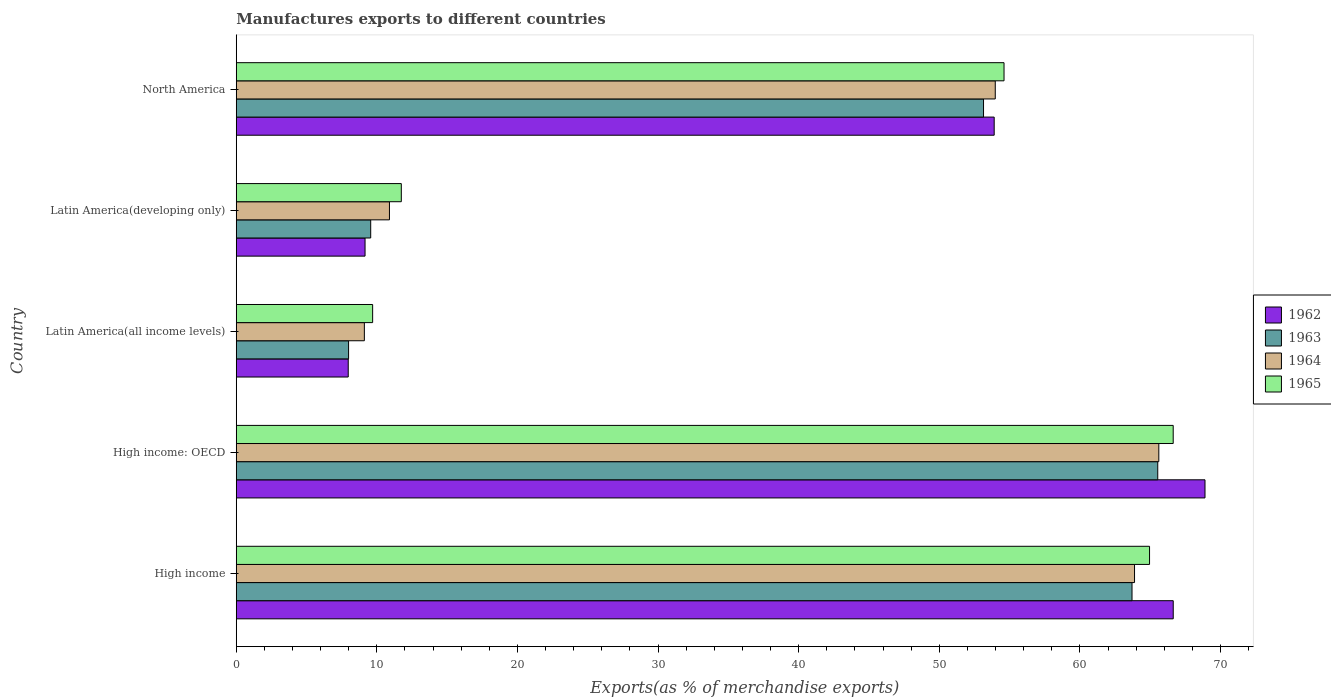How many different coloured bars are there?
Your answer should be very brief. 4. How many groups of bars are there?
Keep it short and to the point. 5. Are the number of bars on each tick of the Y-axis equal?
Make the answer very short. Yes. How many bars are there on the 5th tick from the bottom?
Provide a short and direct response. 4. What is the label of the 4th group of bars from the top?
Make the answer very short. High income: OECD. In how many cases, is the number of bars for a given country not equal to the number of legend labels?
Ensure brevity in your answer.  0. What is the percentage of exports to different countries in 1962 in High income: OECD?
Make the answer very short. 68.9. Across all countries, what is the maximum percentage of exports to different countries in 1963?
Make the answer very short. 65.54. Across all countries, what is the minimum percentage of exports to different countries in 1965?
Ensure brevity in your answer.  9.7. In which country was the percentage of exports to different countries in 1962 maximum?
Offer a very short reply. High income: OECD. In which country was the percentage of exports to different countries in 1962 minimum?
Keep it short and to the point. Latin America(all income levels). What is the total percentage of exports to different countries in 1964 in the graph?
Ensure brevity in your answer.  203.49. What is the difference between the percentage of exports to different countries in 1963 in Latin America(all income levels) and that in North America?
Provide a short and direct response. -45.16. What is the difference between the percentage of exports to different countries in 1962 in Latin America(developing only) and the percentage of exports to different countries in 1963 in North America?
Offer a very short reply. -43.99. What is the average percentage of exports to different countries in 1964 per country?
Give a very brief answer. 40.7. What is the difference between the percentage of exports to different countries in 1963 and percentage of exports to different countries in 1964 in North America?
Provide a short and direct response. -0.84. What is the ratio of the percentage of exports to different countries in 1963 in High income to that in Latin America(all income levels)?
Your answer should be very brief. 7.97. Is the difference between the percentage of exports to different countries in 1963 in High income and High income: OECD greater than the difference between the percentage of exports to different countries in 1964 in High income and High income: OECD?
Your response must be concise. No. What is the difference between the highest and the second highest percentage of exports to different countries in 1965?
Offer a terse response. 1.68. What is the difference between the highest and the lowest percentage of exports to different countries in 1965?
Keep it short and to the point. 56.94. Is the sum of the percentage of exports to different countries in 1962 in Latin America(developing only) and North America greater than the maximum percentage of exports to different countries in 1964 across all countries?
Your answer should be compact. No. Is it the case that in every country, the sum of the percentage of exports to different countries in 1963 and percentage of exports to different countries in 1964 is greater than the sum of percentage of exports to different countries in 1962 and percentage of exports to different countries in 1965?
Your answer should be very brief. No. What does the 2nd bar from the top in Latin America(developing only) represents?
Provide a short and direct response. 1964. What does the 3rd bar from the bottom in North America represents?
Provide a succinct answer. 1964. How many bars are there?
Your answer should be compact. 20. Are all the bars in the graph horizontal?
Your answer should be very brief. Yes. How many countries are there in the graph?
Provide a succinct answer. 5. What is the difference between two consecutive major ticks on the X-axis?
Offer a terse response. 10. Are the values on the major ticks of X-axis written in scientific E-notation?
Give a very brief answer. No. Does the graph contain any zero values?
Your answer should be very brief. No. Where does the legend appear in the graph?
Make the answer very short. Center right. How many legend labels are there?
Provide a short and direct response. 4. How are the legend labels stacked?
Provide a succinct answer. Vertical. What is the title of the graph?
Keep it short and to the point. Manufactures exports to different countries. What is the label or title of the X-axis?
Keep it short and to the point. Exports(as % of merchandise exports). What is the Exports(as % of merchandise exports) of 1962 in High income?
Keep it short and to the point. 66.64. What is the Exports(as % of merchandise exports) in 1963 in High income?
Offer a terse response. 63.71. What is the Exports(as % of merchandise exports) of 1964 in High income?
Your answer should be compact. 63.89. What is the Exports(as % of merchandise exports) in 1965 in High income?
Offer a very short reply. 64.96. What is the Exports(as % of merchandise exports) in 1962 in High income: OECD?
Ensure brevity in your answer.  68.9. What is the Exports(as % of merchandise exports) in 1963 in High income: OECD?
Ensure brevity in your answer.  65.54. What is the Exports(as % of merchandise exports) in 1964 in High income: OECD?
Your response must be concise. 65.61. What is the Exports(as % of merchandise exports) in 1965 in High income: OECD?
Make the answer very short. 66.64. What is the Exports(as % of merchandise exports) in 1962 in Latin America(all income levels)?
Offer a very short reply. 7.96. What is the Exports(as % of merchandise exports) in 1963 in Latin America(all income levels)?
Your answer should be very brief. 7.99. What is the Exports(as % of merchandise exports) of 1964 in Latin America(all income levels)?
Provide a short and direct response. 9.11. What is the Exports(as % of merchandise exports) of 1965 in Latin America(all income levels)?
Keep it short and to the point. 9.7. What is the Exports(as % of merchandise exports) of 1962 in Latin America(developing only)?
Ensure brevity in your answer.  9.16. What is the Exports(as % of merchandise exports) in 1963 in Latin America(developing only)?
Your answer should be compact. 9.56. What is the Exports(as % of merchandise exports) of 1964 in Latin America(developing only)?
Your response must be concise. 10.9. What is the Exports(as % of merchandise exports) of 1965 in Latin America(developing only)?
Your answer should be very brief. 11.74. What is the Exports(as % of merchandise exports) in 1962 in North America?
Provide a short and direct response. 53.91. What is the Exports(as % of merchandise exports) in 1963 in North America?
Provide a short and direct response. 53.15. What is the Exports(as % of merchandise exports) in 1964 in North America?
Make the answer very short. 53.98. What is the Exports(as % of merchandise exports) in 1965 in North America?
Offer a very short reply. 54.61. Across all countries, what is the maximum Exports(as % of merchandise exports) in 1962?
Give a very brief answer. 68.9. Across all countries, what is the maximum Exports(as % of merchandise exports) of 1963?
Offer a very short reply. 65.54. Across all countries, what is the maximum Exports(as % of merchandise exports) of 1964?
Your response must be concise. 65.61. Across all countries, what is the maximum Exports(as % of merchandise exports) in 1965?
Your answer should be compact. 66.64. Across all countries, what is the minimum Exports(as % of merchandise exports) in 1962?
Give a very brief answer. 7.96. Across all countries, what is the minimum Exports(as % of merchandise exports) of 1963?
Offer a terse response. 7.99. Across all countries, what is the minimum Exports(as % of merchandise exports) in 1964?
Your answer should be compact. 9.11. Across all countries, what is the minimum Exports(as % of merchandise exports) of 1965?
Provide a succinct answer. 9.7. What is the total Exports(as % of merchandise exports) in 1962 in the graph?
Your answer should be compact. 206.57. What is the total Exports(as % of merchandise exports) of 1963 in the graph?
Offer a very short reply. 199.94. What is the total Exports(as % of merchandise exports) of 1964 in the graph?
Provide a succinct answer. 203.49. What is the total Exports(as % of merchandise exports) in 1965 in the graph?
Make the answer very short. 207.64. What is the difference between the Exports(as % of merchandise exports) in 1962 in High income and that in High income: OECD?
Keep it short and to the point. -2.26. What is the difference between the Exports(as % of merchandise exports) of 1963 in High income and that in High income: OECD?
Provide a short and direct response. -1.83. What is the difference between the Exports(as % of merchandise exports) of 1964 in High income and that in High income: OECD?
Provide a short and direct response. -1.73. What is the difference between the Exports(as % of merchandise exports) in 1965 in High income and that in High income: OECD?
Your answer should be compact. -1.68. What is the difference between the Exports(as % of merchandise exports) in 1962 in High income and that in Latin America(all income levels)?
Your response must be concise. 58.68. What is the difference between the Exports(as % of merchandise exports) of 1963 in High income and that in Latin America(all income levels)?
Make the answer very short. 55.72. What is the difference between the Exports(as % of merchandise exports) in 1964 in High income and that in Latin America(all income levels)?
Keep it short and to the point. 54.78. What is the difference between the Exports(as % of merchandise exports) of 1965 in High income and that in Latin America(all income levels)?
Keep it short and to the point. 55.25. What is the difference between the Exports(as % of merchandise exports) of 1962 in High income and that in Latin America(developing only)?
Offer a terse response. 57.48. What is the difference between the Exports(as % of merchandise exports) in 1963 in High income and that in Latin America(developing only)?
Provide a succinct answer. 54.15. What is the difference between the Exports(as % of merchandise exports) of 1964 in High income and that in Latin America(developing only)?
Give a very brief answer. 52.99. What is the difference between the Exports(as % of merchandise exports) in 1965 in High income and that in Latin America(developing only)?
Your answer should be very brief. 53.22. What is the difference between the Exports(as % of merchandise exports) of 1962 in High income and that in North America?
Give a very brief answer. 12.73. What is the difference between the Exports(as % of merchandise exports) of 1963 in High income and that in North America?
Give a very brief answer. 10.56. What is the difference between the Exports(as % of merchandise exports) in 1964 in High income and that in North America?
Make the answer very short. 9.9. What is the difference between the Exports(as % of merchandise exports) of 1965 in High income and that in North America?
Your answer should be compact. 10.35. What is the difference between the Exports(as % of merchandise exports) in 1962 in High income: OECD and that in Latin America(all income levels)?
Keep it short and to the point. 60.93. What is the difference between the Exports(as % of merchandise exports) in 1963 in High income: OECD and that in Latin America(all income levels)?
Give a very brief answer. 57.55. What is the difference between the Exports(as % of merchandise exports) in 1964 in High income: OECD and that in Latin America(all income levels)?
Ensure brevity in your answer.  56.5. What is the difference between the Exports(as % of merchandise exports) of 1965 in High income: OECD and that in Latin America(all income levels)?
Your answer should be compact. 56.94. What is the difference between the Exports(as % of merchandise exports) of 1962 in High income: OECD and that in Latin America(developing only)?
Provide a succinct answer. 59.74. What is the difference between the Exports(as % of merchandise exports) of 1963 in High income: OECD and that in Latin America(developing only)?
Offer a very short reply. 55.98. What is the difference between the Exports(as % of merchandise exports) in 1964 in High income: OECD and that in Latin America(developing only)?
Keep it short and to the point. 54.72. What is the difference between the Exports(as % of merchandise exports) of 1965 in High income: OECD and that in Latin America(developing only)?
Provide a short and direct response. 54.9. What is the difference between the Exports(as % of merchandise exports) of 1962 in High income: OECD and that in North America?
Your response must be concise. 14.99. What is the difference between the Exports(as % of merchandise exports) in 1963 in High income: OECD and that in North America?
Your response must be concise. 12.39. What is the difference between the Exports(as % of merchandise exports) of 1964 in High income: OECD and that in North America?
Your response must be concise. 11.63. What is the difference between the Exports(as % of merchandise exports) of 1965 in High income: OECD and that in North America?
Give a very brief answer. 12.03. What is the difference between the Exports(as % of merchandise exports) of 1962 in Latin America(all income levels) and that in Latin America(developing only)?
Ensure brevity in your answer.  -1.2. What is the difference between the Exports(as % of merchandise exports) of 1963 in Latin America(all income levels) and that in Latin America(developing only)?
Offer a terse response. -1.57. What is the difference between the Exports(as % of merchandise exports) of 1964 in Latin America(all income levels) and that in Latin America(developing only)?
Give a very brief answer. -1.78. What is the difference between the Exports(as % of merchandise exports) in 1965 in Latin America(all income levels) and that in Latin America(developing only)?
Provide a short and direct response. -2.04. What is the difference between the Exports(as % of merchandise exports) in 1962 in Latin America(all income levels) and that in North America?
Make the answer very short. -45.94. What is the difference between the Exports(as % of merchandise exports) of 1963 in Latin America(all income levels) and that in North America?
Your answer should be very brief. -45.16. What is the difference between the Exports(as % of merchandise exports) of 1964 in Latin America(all income levels) and that in North America?
Offer a terse response. -44.87. What is the difference between the Exports(as % of merchandise exports) in 1965 in Latin America(all income levels) and that in North America?
Keep it short and to the point. -44.91. What is the difference between the Exports(as % of merchandise exports) of 1962 in Latin America(developing only) and that in North America?
Your answer should be compact. -44.75. What is the difference between the Exports(as % of merchandise exports) in 1963 in Latin America(developing only) and that in North America?
Your response must be concise. -43.59. What is the difference between the Exports(as % of merchandise exports) in 1964 in Latin America(developing only) and that in North America?
Keep it short and to the point. -43.09. What is the difference between the Exports(as % of merchandise exports) in 1965 in Latin America(developing only) and that in North America?
Provide a succinct answer. -42.87. What is the difference between the Exports(as % of merchandise exports) in 1962 in High income and the Exports(as % of merchandise exports) in 1963 in High income: OECD?
Make the answer very short. 1.1. What is the difference between the Exports(as % of merchandise exports) in 1962 in High income and the Exports(as % of merchandise exports) in 1964 in High income: OECD?
Provide a short and direct response. 1.03. What is the difference between the Exports(as % of merchandise exports) of 1962 in High income and the Exports(as % of merchandise exports) of 1965 in High income: OECD?
Offer a terse response. 0. What is the difference between the Exports(as % of merchandise exports) of 1963 in High income and the Exports(as % of merchandise exports) of 1964 in High income: OECD?
Provide a succinct answer. -1.91. What is the difference between the Exports(as % of merchandise exports) in 1963 in High income and the Exports(as % of merchandise exports) in 1965 in High income: OECD?
Offer a very short reply. -2.93. What is the difference between the Exports(as % of merchandise exports) of 1964 in High income and the Exports(as % of merchandise exports) of 1965 in High income: OECD?
Give a very brief answer. -2.75. What is the difference between the Exports(as % of merchandise exports) of 1962 in High income and the Exports(as % of merchandise exports) of 1963 in Latin America(all income levels)?
Your answer should be very brief. 58.65. What is the difference between the Exports(as % of merchandise exports) in 1962 in High income and the Exports(as % of merchandise exports) in 1964 in Latin America(all income levels)?
Offer a terse response. 57.53. What is the difference between the Exports(as % of merchandise exports) of 1962 in High income and the Exports(as % of merchandise exports) of 1965 in Latin America(all income levels)?
Ensure brevity in your answer.  56.94. What is the difference between the Exports(as % of merchandise exports) of 1963 in High income and the Exports(as % of merchandise exports) of 1964 in Latin America(all income levels)?
Your answer should be compact. 54.6. What is the difference between the Exports(as % of merchandise exports) of 1963 in High income and the Exports(as % of merchandise exports) of 1965 in Latin America(all income levels)?
Offer a terse response. 54.01. What is the difference between the Exports(as % of merchandise exports) in 1964 in High income and the Exports(as % of merchandise exports) in 1965 in Latin America(all income levels)?
Provide a succinct answer. 54.19. What is the difference between the Exports(as % of merchandise exports) in 1962 in High income and the Exports(as % of merchandise exports) in 1963 in Latin America(developing only)?
Keep it short and to the point. 57.08. What is the difference between the Exports(as % of merchandise exports) in 1962 in High income and the Exports(as % of merchandise exports) in 1964 in Latin America(developing only)?
Your answer should be very brief. 55.74. What is the difference between the Exports(as % of merchandise exports) in 1962 in High income and the Exports(as % of merchandise exports) in 1965 in Latin America(developing only)?
Keep it short and to the point. 54.9. What is the difference between the Exports(as % of merchandise exports) in 1963 in High income and the Exports(as % of merchandise exports) in 1964 in Latin America(developing only)?
Ensure brevity in your answer.  52.81. What is the difference between the Exports(as % of merchandise exports) of 1963 in High income and the Exports(as % of merchandise exports) of 1965 in Latin America(developing only)?
Provide a short and direct response. 51.97. What is the difference between the Exports(as % of merchandise exports) of 1964 in High income and the Exports(as % of merchandise exports) of 1965 in Latin America(developing only)?
Your answer should be compact. 52.15. What is the difference between the Exports(as % of merchandise exports) of 1962 in High income and the Exports(as % of merchandise exports) of 1963 in North America?
Keep it short and to the point. 13.49. What is the difference between the Exports(as % of merchandise exports) in 1962 in High income and the Exports(as % of merchandise exports) in 1964 in North America?
Offer a terse response. 12.66. What is the difference between the Exports(as % of merchandise exports) of 1962 in High income and the Exports(as % of merchandise exports) of 1965 in North America?
Make the answer very short. 12.03. What is the difference between the Exports(as % of merchandise exports) in 1963 in High income and the Exports(as % of merchandise exports) in 1964 in North America?
Give a very brief answer. 9.73. What is the difference between the Exports(as % of merchandise exports) in 1963 in High income and the Exports(as % of merchandise exports) in 1965 in North America?
Provide a short and direct response. 9.1. What is the difference between the Exports(as % of merchandise exports) of 1964 in High income and the Exports(as % of merchandise exports) of 1965 in North America?
Offer a terse response. 9.28. What is the difference between the Exports(as % of merchandise exports) of 1962 in High income: OECD and the Exports(as % of merchandise exports) of 1963 in Latin America(all income levels)?
Offer a terse response. 60.91. What is the difference between the Exports(as % of merchandise exports) of 1962 in High income: OECD and the Exports(as % of merchandise exports) of 1964 in Latin America(all income levels)?
Keep it short and to the point. 59.79. What is the difference between the Exports(as % of merchandise exports) in 1962 in High income: OECD and the Exports(as % of merchandise exports) in 1965 in Latin America(all income levels)?
Provide a succinct answer. 59.2. What is the difference between the Exports(as % of merchandise exports) in 1963 in High income: OECD and the Exports(as % of merchandise exports) in 1964 in Latin America(all income levels)?
Offer a terse response. 56.43. What is the difference between the Exports(as % of merchandise exports) of 1963 in High income: OECD and the Exports(as % of merchandise exports) of 1965 in Latin America(all income levels)?
Offer a very short reply. 55.84. What is the difference between the Exports(as % of merchandise exports) of 1964 in High income: OECD and the Exports(as % of merchandise exports) of 1965 in Latin America(all income levels)?
Offer a very short reply. 55.91. What is the difference between the Exports(as % of merchandise exports) of 1962 in High income: OECD and the Exports(as % of merchandise exports) of 1963 in Latin America(developing only)?
Offer a terse response. 59.34. What is the difference between the Exports(as % of merchandise exports) in 1962 in High income: OECD and the Exports(as % of merchandise exports) in 1964 in Latin America(developing only)?
Keep it short and to the point. 58. What is the difference between the Exports(as % of merchandise exports) in 1962 in High income: OECD and the Exports(as % of merchandise exports) in 1965 in Latin America(developing only)?
Give a very brief answer. 57.16. What is the difference between the Exports(as % of merchandise exports) of 1963 in High income: OECD and the Exports(as % of merchandise exports) of 1964 in Latin America(developing only)?
Your answer should be very brief. 54.64. What is the difference between the Exports(as % of merchandise exports) in 1963 in High income: OECD and the Exports(as % of merchandise exports) in 1965 in Latin America(developing only)?
Your answer should be very brief. 53.8. What is the difference between the Exports(as % of merchandise exports) of 1964 in High income: OECD and the Exports(as % of merchandise exports) of 1965 in Latin America(developing only)?
Make the answer very short. 53.87. What is the difference between the Exports(as % of merchandise exports) of 1962 in High income: OECD and the Exports(as % of merchandise exports) of 1963 in North America?
Your answer should be very brief. 15.75. What is the difference between the Exports(as % of merchandise exports) of 1962 in High income: OECD and the Exports(as % of merchandise exports) of 1964 in North America?
Your response must be concise. 14.92. What is the difference between the Exports(as % of merchandise exports) in 1962 in High income: OECD and the Exports(as % of merchandise exports) in 1965 in North America?
Provide a succinct answer. 14.29. What is the difference between the Exports(as % of merchandise exports) in 1963 in High income: OECD and the Exports(as % of merchandise exports) in 1964 in North America?
Provide a succinct answer. 11.56. What is the difference between the Exports(as % of merchandise exports) of 1963 in High income: OECD and the Exports(as % of merchandise exports) of 1965 in North America?
Offer a terse response. 10.93. What is the difference between the Exports(as % of merchandise exports) in 1964 in High income: OECD and the Exports(as % of merchandise exports) in 1965 in North America?
Keep it short and to the point. 11.01. What is the difference between the Exports(as % of merchandise exports) of 1962 in Latin America(all income levels) and the Exports(as % of merchandise exports) of 1963 in Latin America(developing only)?
Keep it short and to the point. -1.6. What is the difference between the Exports(as % of merchandise exports) in 1962 in Latin America(all income levels) and the Exports(as % of merchandise exports) in 1964 in Latin America(developing only)?
Your response must be concise. -2.93. What is the difference between the Exports(as % of merchandise exports) of 1962 in Latin America(all income levels) and the Exports(as % of merchandise exports) of 1965 in Latin America(developing only)?
Offer a very short reply. -3.78. What is the difference between the Exports(as % of merchandise exports) of 1963 in Latin America(all income levels) and the Exports(as % of merchandise exports) of 1964 in Latin America(developing only)?
Give a very brief answer. -2.91. What is the difference between the Exports(as % of merchandise exports) of 1963 in Latin America(all income levels) and the Exports(as % of merchandise exports) of 1965 in Latin America(developing only)?
Provide a succinct answer. -3.75. What is the difference between the Exports(as % of merchandise exports) of 1964 in Latin America(all income levels) and the Exports(as % of merchandise exports) of 1965 in Latin America(developing only)?
Offer a very short reply. -2.63. What is the difference between the Exports(as % of merchandise exports) in 1962 in Latin America(all income levels) and the Exports(as % of merchandise exports) in 1963 in North America?
Make the answer very short. -45.18. What is the difference between the Exports(as % of merchandise exports) of 1962 in Latin America(all income levels) and the Exports(as % of merchandise exports) of 1964 in North America?
Ensure brevity in your answer.  -46.02. What is the difference between the Exports(as % of merchandise exports) of 1962 in Latin America(all income levels) and the Exports(as % of merchandise exports) of 1965 in North America?
Provide a short and direct response. -46.64. What is the difference between the Exports(as % of merchandise exports) of 1963 in Latin America(all income levels) and the Exports(as % of merchandise exports) of 1964 in North America?
Give a very brief answer. -45.99. What is the difference between the Exports(as % of merchandise exports) of 1963 in Latin America(all income levels) and the Exports(as % of merchandise exports) of 1965 in North America?
Your response must be concise. -46.62. What is the difference between the Exports(as % of merchandise exports) in 1964 in Latin America(all income levels) and the Exports(as % of merchandise exports) in 1965 in North America?
Your response must be concise. -45.49. What is the difference between the Exports(as % of merchandise exports) of 1962 in Latin America(developing only) and the Exports(as % of merchandise exports) of 1963 in North America?
Provide a short and direct response. -43.99. What is the difference between the Exports(as % of merchandise exports) of 1962 in Latin America(developing only) and the Exports(as % of merchandise exports) of 1964 in North America?
Ensure brevity in your answer.  -44.82. What is the difference between the Exports(as % of merchandise exports) in 1962 in Latin America(developing only) and the Exports(as % of merchandise exports) in 1965 in North America?
Your answer should be compact. -45.45. What is the difference between the Exports(as % of merchandise exports) of 1963 in Latin America(developing only) and the Exports(as % of merchandise exports) of 1964 in North America?
Your answer should be compact. -44.42. What is the difference between the Exports(as % of merchandise exports) of 1963 in Latin America(developing only) and the Exports(as % of merchandise exports) of 1965 in North America?
Your response must be concise. -45.04. What is the difference between the Exports(as % of merchandise exports) of 1964 in Latin America(developing only) and the Exports(as % of merchandise exports) of 1965 in North America?
Keep it short and to the point. -43.71. What is the average Exports(as % of merchandise exports) in 1962 per country?
Ensure brevity in your answer.  41.31. What is the average Exports(as % of merchandise exports) of 1963 per country?
Provide a succinct answer. 39.99. What is the average Exports(as % of merchandise exports) of 1964 per country?
Ensure brevity in your answer.  40.7. What is the average Exports(as % of merchandise exports) of 1965 per country?
Provide a succinct answer. 41.53. What is the difference between the Exports(as % of merchandise exports) in 1962 and Exports(as % of merchandise exports) in 1963 in High income?
Your answer should be very brief. 2.93. What is the difference between the Exports(as % of merchandise exports) of 1962 and Exports(as % of merchandise exports) of 1964 in High income?
Your response must be concise. 2.75. What is the difference between the Exports(as % of merchandise exports) in 1962 and Exports(as % of merchandise exports) in 1965 in High income?
Offer a terse response. 1.68. What is the difference between the Exports(as % of merchandise exports) of 1963 and Exports(as % of merchandise exports) of 1964 in High income?
Ensure brevity in your answer.  -0.18. What is the difference between the Exports(as % of merchandise exports) of 1963 and Exports(as % of merchandise exports) of 1965 in High income?
Give a very brief answer. -1.25. What is the difference between the Exports(as % of merchandise exports) of 1964 and Exports(as % of merchandise exports) of 1965 in High income?
Your response must be concise. -1.07. What is the difference between the Exports(as % of merchandise exports) in 1962 and Exports(as % of merchandise exports) in 1963 in High income: OECD?
Give a very brief answer. 3.36. What is the difference between the Exports(as % of merchandise exports) in 1962 and Exports(as % of merchandise exports) in 1964 in High income: OECD?
Offer a very short reply. 3.28. What is the difference between the Exports(as % of merchandise exports) of 1962 and Exports(as % of merchandise exports) of 1965 in High income: OECD?
Your answer should be compact. 2.26. What is the difference between the Exports(as % of merchandise exports) in 1963 and Exports(as % of merchandise exports) in 1964 in High income: OECD?
Ensure brevity in your answer.  -0.08. What is the difference between the Exports(as % of merchandise exports) in 1963 and Exports(as % of merchandise exports) in 1965 in High income: OECD?
Your answer should be compact. -1.1. What is the difference between the Exports(as % of merchandise exports) in 1964 and Exports(as % of merchandise exports) in 1965 in High income: OECD?
Provide a succinct answer. -1.02. What is the difference between the Exports(as % of merchandise exports) of 1962 and Exports(as % of merchandise exports) of 1963 in Latin America(all income levels)?
Your answer should be very brief. -0.02. What is the difference between the Exports(as % of merchandise exports) in 1962 and Exports(as % of merchandise exports) in 1964 in Latin America(all income levels)?
Your response must be concise. -1.15. What is the difference between the Exports(as % of merchandise exports) of 1962 and Exports(as % of merchandise exports) of 1965 in Latin America(all income levels)?
Keep it short and to the point. -1.74. What is the difference between the Exports(as % of merchandise exports) of 1963 and Exports(as % of merchandise exports) of 1964 in Latin America(all income levels)?
Give a very brief answer. -1.12. What is the difference between the Exports(as % of merchandise exports) in 1963 and Exports(as % of merchandise exports) in 1965 in Latin America(all income levels)?
Offer a very short reply. -1.71. What is the difference between the Exports(as % of merchandise exports) of 1964 and Exports(as % of merchandise exports) of 1965 in Latin America(all income levels)?
Provide a short and direct response. -0.59. What is the difference between the Exports(as % of merchandise exports) in 1962 and Exports(as % of merchandise exports) in 1963 in Latin America(developing only)?
Offer a terse response. -0.4. What is the difference between the Exports(as % of merchandise exports) of 1962 and Exports(as % of merchandise exports) of 1964 in Latin America(developing only)?
Offer a very short reply. -1.74. What is the difference between the Exports(as % of merchandise exports) of 1962 and Exports(as % of merchandise exports) of 1965 in Latin America(developing only)?
Give a very brief answer. -2.58. What is the difference between the Exports(as % of merchandise exports) in 1963 and Exports(as % of merchandise exports) in 1964 in Latin America(developing only)?
Your answer should be compact. -1.33. What is the difference between the Exports(as % of merchandise exports) of 1963 and Exports(as % of merchandise exports) of 1965 in Latin America(developing only)?
Keep it short and to the point. -2.18. What is the difference between the Exports(as % of merchandise exports) of 1964 and Exports(as % of merchandise exports) of 1965 in Latin America(developing only)?
Offer a very short reply. -0.84. What is the difference between the Exports(as % of merchandise exports) of 1962 and Exports(as % of merchandise exports) of 1963 in North America?
Offer a very short reply. 0.76. What is the difference between the Exports(as % of merchandise exports) of 1962 and Exports(as % of merchandise exports) of 1964 in North America?
Keep it short and to the point. -0.08. What is the difference between the Exports(as % of merchandise exports) of 1962 and Exports(as % of merchandise exports) of 1965 in North America?
Give a very brief answer. -0.7. What is the difference between the Exports(as % of merchandise exports) in 1963 and Exports(as % of merchandise exports) in 1964 in North America?
Provide a short and direct response. -0.84. What is the difference between the Exports(as % of merchandise exports) of 1963 and Exports(as % of merchandise exports) of 1965 in North America?
Your response must be concise. -1.46. What is the difference between the Exports(as % of merchandise exports) in 1964 and Exports(as % of merchandise exports) in 1965 in North America?
Keep it short and to the point. -0.62. What is the ratio of the Exports(as % of merchandise exports) in 1962 in High income to that in High income: OECD?
Your response must be concise. 0.97. What is the ratio of the Exports(as % of merchandise exports) in 1963 in High income to that in High income: OECD?
Make the answer very short. 0.97. What is the ratio of the Exports(as % of merchandise exports) of 1964 in High income to that in High income: OECD?
Give a very brief answer. 0.97. What is the ratio of the Exports(as % of merchandise exports) of 1965 in High income to that in High income: OECD?
Provide a short and direct response. 0.97. What is the ratio of the Exports(as % of merchandise exports) of 1962 in High income to that in Latin America(all income levels)?
Provide a short and direct response. 8.37. What is the ratio of the Exports(as % of merchandise exports) in 1963 in High income to that in Latin America(all income levels)?
Provide a short and direct response. 7.97. What is the ratio of the Exports(as % of merchandise exports) in 1964 in High income to that in Latin America(all income levels)?
Provide a succinct answer. 7.01. What is the ratio of the Exports(as % of merchandise exports) of 1965 in High income to that in Latin America(all income levels)?
Your response must be concise. 6.7. What is the ratio of the Exports(as % of merchandise exports) of 1962 in High income to that in Latin America(developing only)?
Give a very brief answer. 7.28. What is the ratio of the Exports(as % of merchandise exports) in 1963 in High income to that in Latin America(developing only)?
Offer a terse response. 6.66. What is the ratio of the Exports(as % of merchandise exports) of 1964 in High income to that in Latin America(developing only)?
Provide a short and direct response. 5.86. What is the ratio of the Exports(as % of merchandise exports) of 1965 in High income to that in Latin America(developing only)?
Provide a short and direct response. 5.53. What is the ratio of the Exports(as % of merchandise exports) of 1962 in High income to that in North America?
Give a very brief answer. 1.24. What is the ratio of the Exports(as % of merchandise exports) of 1963 in High income to that in North America?
Make the answer very short. 1.2. What is the ratio of the Exports(as % of merchandise exports) of 1964 in High income to that in North America?
Ensure brevity in your answer.  1.18. What is the ratio of the Exports(as % of merchandise exports) in 1965 in High income to that in North America?
Give a very brief answer. 1.19. What is the ratio of the Exports(as % of merchandise exports) of 1962 in High income: OECD to that in Latin America(all income levels)?
Offer a very short reply. 8.65. What is the ratio of the Exports(as % of merchandise exports) of 1963 in High income: OECD to that in Latin America(all income levels)?
Give a very brief answer. 8.2. What is the ratio of the Exports(as % of merchandise exports) of 1964 in High income: OECD to that in Latin America(all income levels)?
Your answer should be compact. 7.2. What is the ratio of the Exports(as % of merchandise exports) in 1965 in High income: OECD to that in Latin America(all income levels)?
Provide a succinct answer. 6.87. What is the ratio of the Exports(as % of merchandise exports) of 1962 in High income: OECD to that in Latin America(developing only)?
Give a very brief answer. 7.52. What is the ratio of the Exports(as % of merchandise exports) in 1963 in High income: OECD to that in Latin America(developing only)?
Provide a short and direct response. 6.85. What is the ratio of the Exports(as % of merchandise exports) in 1964 in High income: OECD to that in Latin America(developing only)?
Ensure brevity in your answer.  6.02. What is the ratio of the Exports(as % of merchandise exports) of 1965 in High income: OECD to that in Latin America(developing only)?
Offer a very short reply. 5.68. What is the ratio of the Exports(as % of merchandise exports) in 1962 in High income: OECD to that in North America?
Your answer should be compact. 1.28. What is the ratio of the Exports(as % of merchandise exports) in 1963 in High income: OECD to that in North America?
Ensure brevity in your answer.  1.23. What is the ratio of the Exports(as % of merchandise exports) in 1964 in High income: OECD to that in North America?
Your answer should be very brief. 1.22. What is the ratio of the Exports(as % of merchandise exports) of 1965 in High income: OECD to that in North America?
Offer a very short reply. 1.22. What is the ratio of the Exports(as % of merchandise exports) in 1962 in Latin America(all income levels) to that in Latin America(developing only)?
Offer a very short reply. 0.87. What is the ratio of the Exports(as % of merchandise exports) in 1963 in Latin America(all income levels) to that in Latin America(developing only)?
Your answer should be very brief. 0.84. What is the ratio of the Exports(as % of merchandise exports) of 1964 in Latin America(all income levels) to that in Latin America(developing only)?
Your response must be concise. 0.84. What is the ratio of the Exports(as % of merchandise exports) in 1965 in Latin America(all income levels) to that in Latin America(developing only)?
Your answer should be very brief. 0.83. What is the ratio of the Exports(as % of merchandise exports) in 1962 in Latin America(all income levels) to that in North America?
Your answer should be compact. 0.15. What is the ratio of the Exports(as % of merchandise exports) of 1963 in Latin America(all income levels) to that in North America?
Keep it short and to the point. 0.15. What is the ratio of the Exports(as % of merchandise exports) of 1964 in Latin America(all income levels) to that in North America?
Your response must be concise. 0.17. What is the ratio of the Exports(as % of merchandise exports) of 1965 in Latin America(all income levels) to that in North America?
Your answer should be compact. 0.18. What is the ratio of the Exports(as % of merchandise exports) in 1962 in Latin America(developing only) to that in North America?
Keep it short and to the point. 0.17. What is the ratio of the Exports(as % of merchandise exports) of 1963 in Latin America(developing only) to that in North America?
Provide a succinct answer. 0.18. What is the ratio of the Exports(as % of merchandise exports) of 1964 in Latin America(developing only) to that in North America?
Your answer should be compact. 0.2. What is the ratio of the Exports(as % of merchandise exports) in 1965 in Latin America(developing only) to that in North America?
Offer a terse response. 0.21. What is the difference between the highest and the second highest Exports(as % of merchandise exports) in 1962?
Keep it short and to the point. 2.26. What is the difference between the highest and the second highest Exports(as % of merchandise exports) in 1963?
Keep it short and to the point. 1.83. What is the difference between the highest and the second highest Exports(as % of merchandise exports) in 1964?
Make the answer very short. 1.73. What is the difference between the highest and the second highest Exports(as % of merchandise exports) in 1965?
Your answer should be compact. 1.68. What is the difference between the highest and the lowest Exports(as % of merchandise exports) of 1962?
Give a very brief answer. 60.93. What is the difference between the highest and the lowest Exports(as % of merchandise exports) in 1963?
Your answer should be very brief. 57.55. What is the difference between the highest and the lowest Exports(as % of merchandise exports) of 1964?
Give a very brief answer. 56.5. What is the difference between the highest and the lowest Exports(as % of merchandise exports) of 1965?
Offer a very short reply. 56.94. 